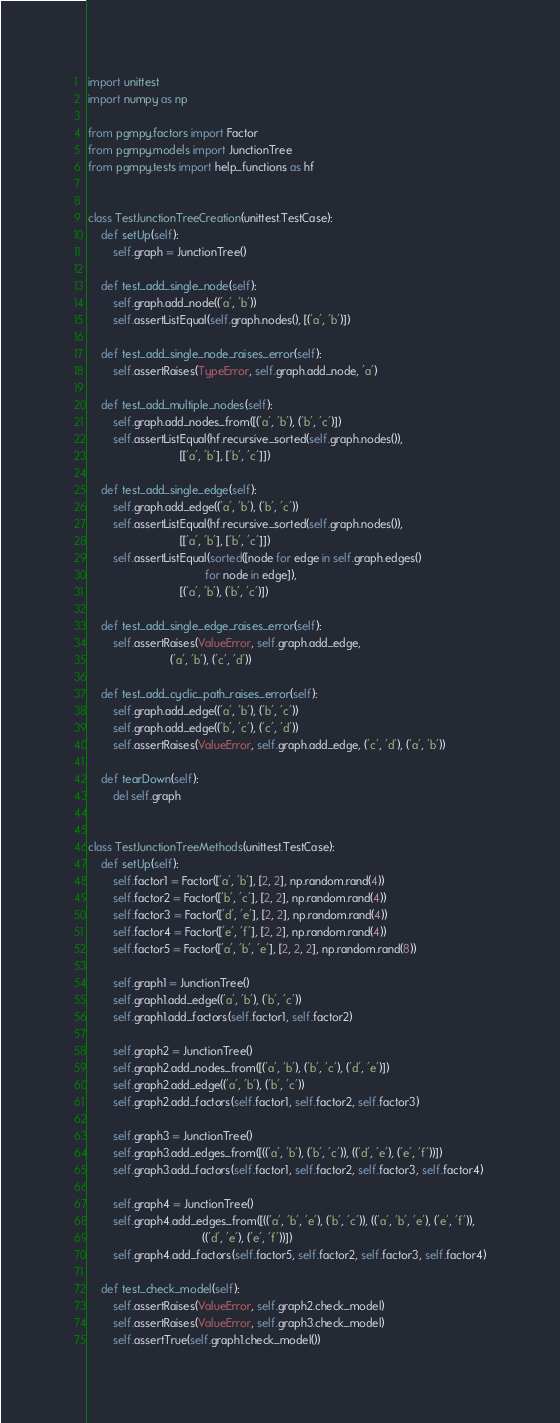Convert code to text. <code><loc_0><loc_0><loc_500><loc_500><_Python_>import unittest
import numpy as np

from pgmpy.factors import Factor
from pgmpy.models import JunctionTree
from pgmpy.tests import help_functions as hf


class TestJunctionTreeCreation(unittest.TestCase):
    def setUp(self):
        self.graph = JunctionTree()

    def test_add_single_node(self):
        self.graph.add_node(('a', 'b'))
        self.assertListEqual(self.graph.nodes(), [('a', 'b')])

    def test_add_single_node_raises_error(self):
        self.assertRaises(TypeError, self.graph.add_node, 'a')

    def test_add_multiple_nodes(self):
        self.graph.add_nodes_from([('a', 'b'), ('b', 'c')])
        self.assertListEqual(hf.recursive_sorted(self.graph.nodes()),
                             [['a', 'b'], ['b', 'c']])

    def test_add_single_edge(self):
        self.graph.add_edge(('a', 'b'), ('b', 'c'))
        self.assertListEqual(hf.recursive_sorted(self.graph.nodes()),
                             [['a', 'b'], ['b', 'c']])
        self.assertListEqual(sorted([node for edge in self.graph.edges()
                                     for node in edge]),
                             [('a', 'b'), ('b', 'c')])

    def test_add_single_edge_raises_error(self):
        self.assertRaises(ValueError, self.graph.add_edge,
                          ('a', 'b'), ('c', 'd'))

    def test_add_cyclic_path_raises_error(self):
        self.graph.add_edge(('a', 'b'), ('b', 'c'))
        self.graph.add_edge(('b', 'c'), ('c', 'd'))
        self.assertRaises(ValueError, self.graph.add_edge, ('c', 'd'), ('a', 'b'))

    def tearDown(self):
        del self.graph


class TestJunctionTreeMethods(unittest.TestCase):
    def setUp(self):
        self.factor1 = Factor(['a', 'b'], [2, 2], np.random.rand(4))
        self.factor2 = Factor(['b', 'c'], [2, 2], np.random.rand(4))
        self.factor3 = Factor(['d', 'e'], [2, 2], np.random.rand(4))
        self.factor4 = Factor(['e', 'f'], [2, 2], np.random.rand(4))
        self.factor5 = Factor(['a', 'b', 'e'], [2, 2, 2], np.random.rand(8))

        self.graph1 = JunctionTree()
        self.graph1.add_edge(('a', 'b'), ('b', 'c'))
        self.graph1.add_factors(self.factor1, self.factor2)

        self.graph2 = JunctionTree()
        self.graph2.add_nodes_from([('a', 'b'), ('b', 'c'), ('d', 'e')])
        self.graph2.add_edge(('a', 'b'), ('b', 'c'))
        self.graph2.add_factors(self.factor1, self.factor2, self.factor3)

        self.graph3 = JunctionTree()
        self.graph3.add_edges_from([(('a', 'b'), ('b', 'c')), (('d', 'e'), ('e', 'f'))])
        self.graph3.add_factors(self.factor1, self.factor2, self.factor3, self.factor4)

        self.graph4 = JunctionTree()
        self.graph4.add_edges_from([(('a', 'b', 'e'), ('b', 'c')), (('a', 'b', 'e'), ('e', 'f')),
                                    (('d', 'e'), ('e', 'f'))])
        self.graph4.add_factors(self.factor5, self.factor2, self.factor3, self.factor4)

    def test_check_model(self):
        self.assertRaises(ValueError, self.graph2.check_model)
        self.assertRaises(ValueError, self.graph3.check_model)
        self.assertTrue(self.graph1.check_model())</code> 